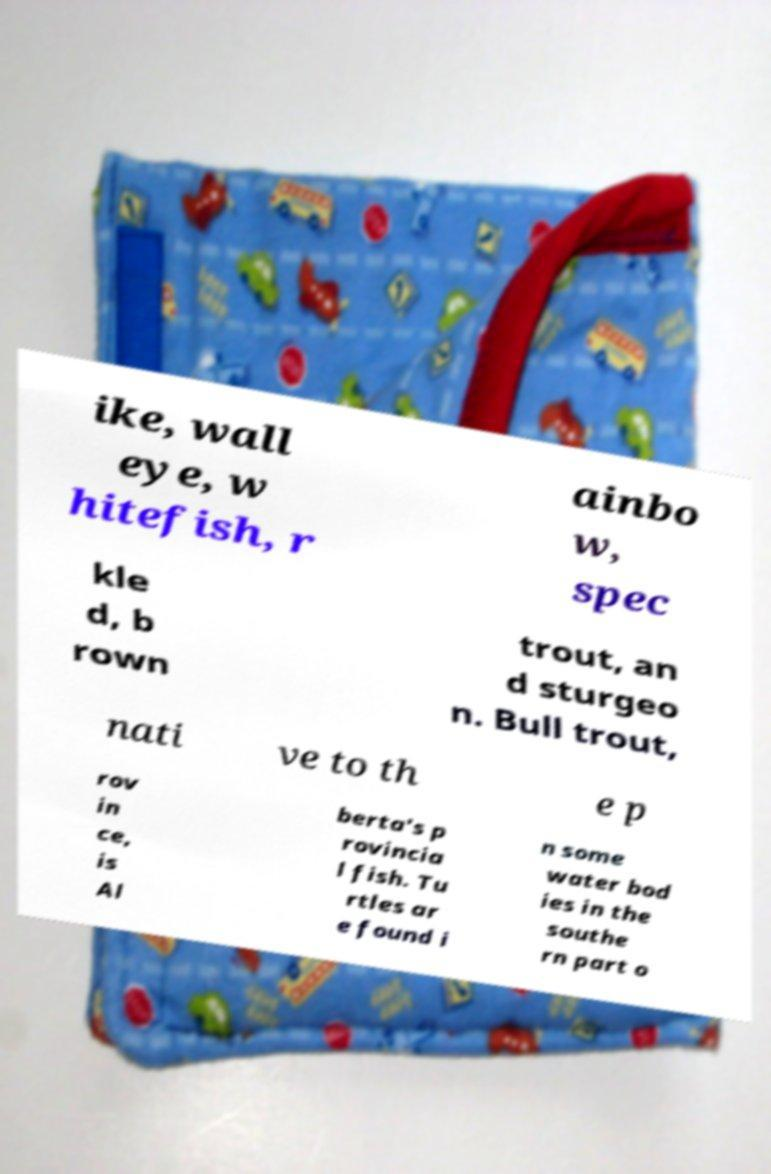What messages or text are displayed in this image? I need them in a readable, typed format. ike, wall eye, w hitefish, r ainbo w, spec kle d, b rown trout, an d sturgeo n. Bull trout, nati ve to th e p rov in ce, is Al berta's p rovincia l fish. Tu rtles ar e found i n some water bod ies in the southe rn part o 